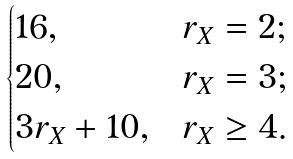Convert formula to latex. <formula><loc_0><loc_0><loc_500><loc_500>\begin{cases} 1 6 , & r _ { X } = 2 ; \\ 2 0 , & r _ { X } = 3 ; \\ 3 r _ { X } + 1 0 , & r _ { X } \geq 4 . \end{cases}</formula> 